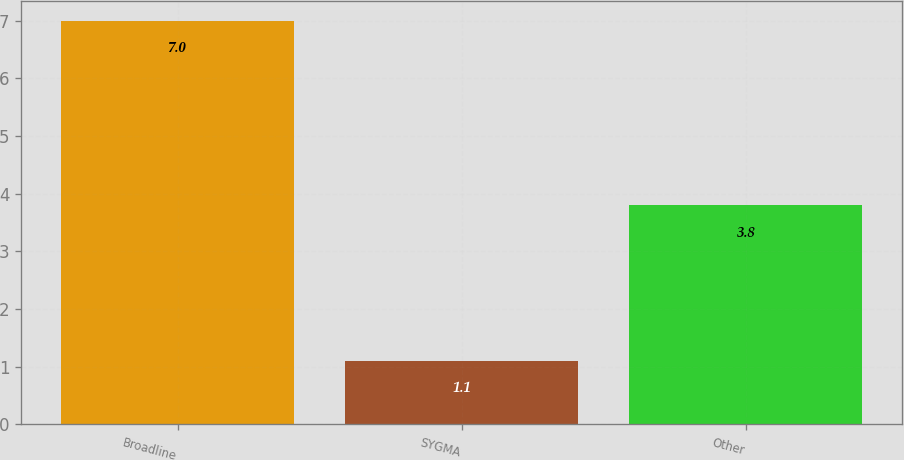Convert chart. <chart><loc_0><loc_0><loc_500><loc_500><bar_chart><fcel>Broadline<fcel>SYGMA<fcel>Other<nl><fcel>7<fcel>1.1<fcel>3.8<nl></chart> 